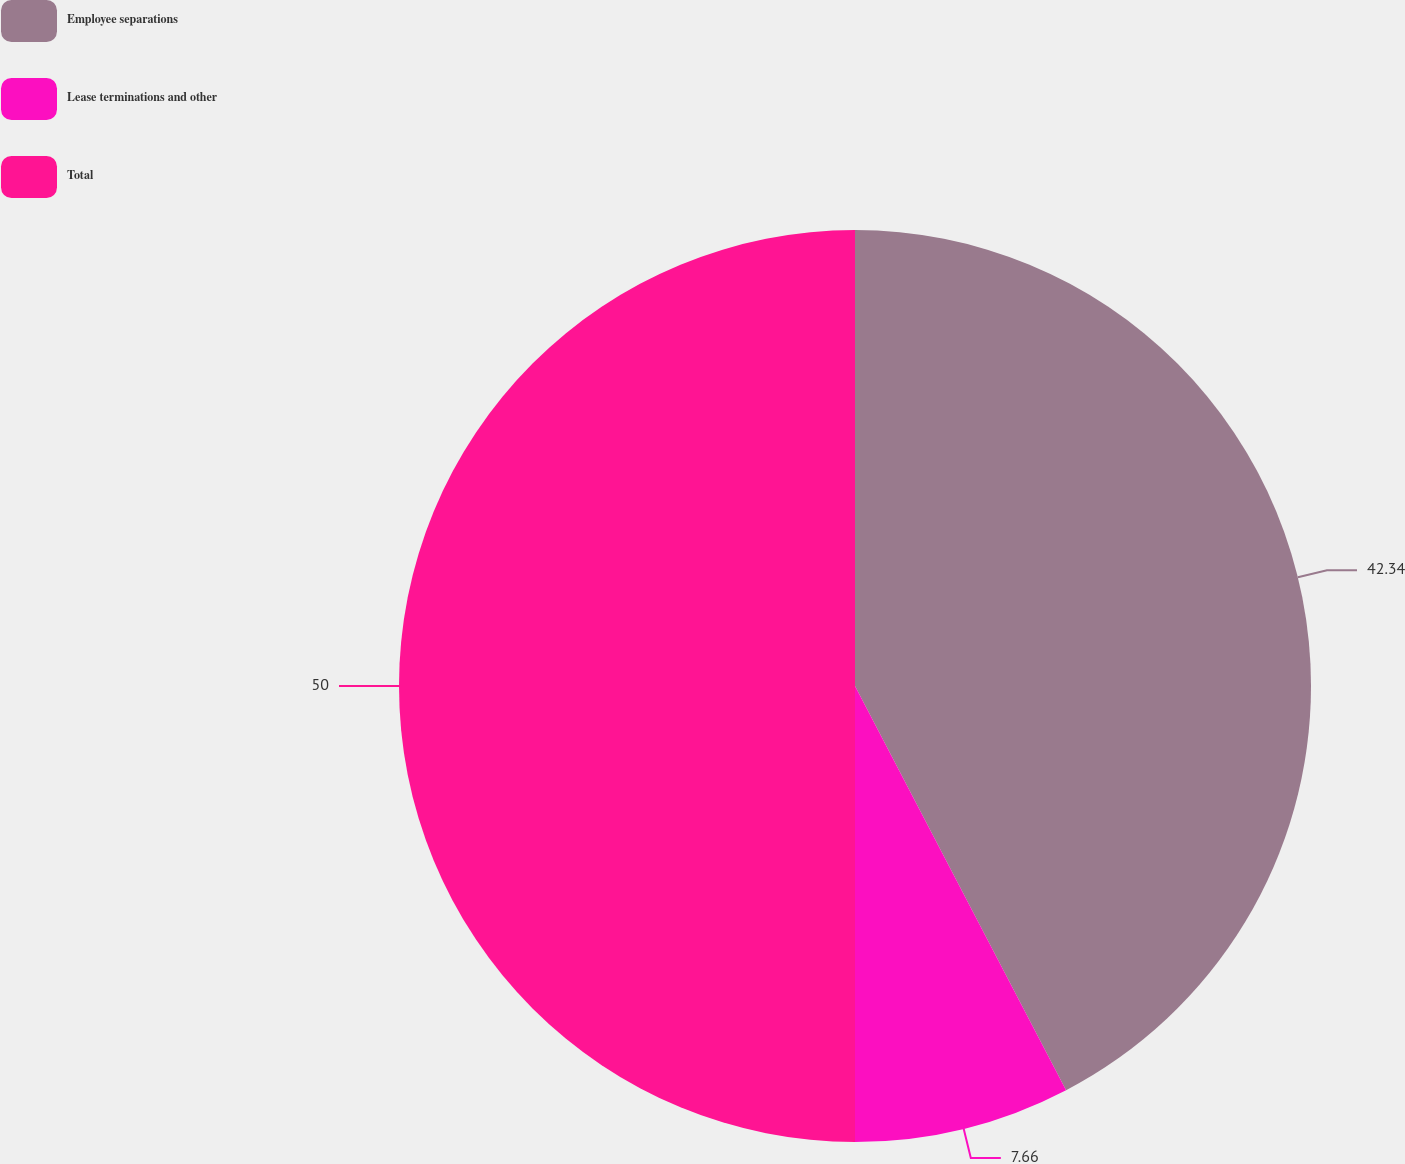Convert chart. <chart><loc_0><loc_0><loc_500><loc_500><pie_chart><fcel>Employee separations<fcel>Lease terminations and other<fcel>Total<nl><fcel>42.34%<fcel>7.66%<fcel>50.0%<nl></chart> 